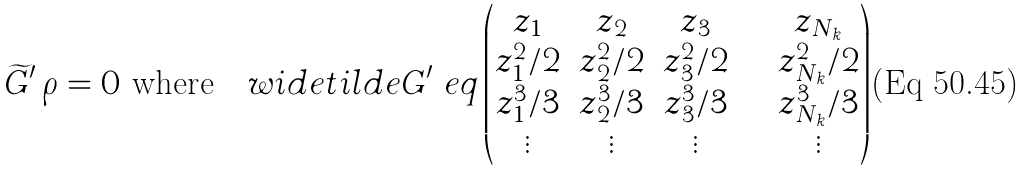<formula> <loc_0><loc_0><loc_500><loc_500>\widetilde { G } ^ { \prime } \, { \rho } = 0 \ { \text {where} } \ \ \ w i d e t i l d e { G } ^ { \prime } \ e q \begin{pmatrix} z _ { 1 } & z _ { 2 } & z _ { 3 } & \cdots & z _ { N _ { k } } \\ z _ { 1 } ^ { 2 } / 2 & z _ { 2 } ^ { 2 } / 2 & z _ { 3 } ^ { 2 } / 2 & \cdots & z _ { N _ { k } } ^ { 2 } / 2 \\ z _ { 1 } ^ { 3 } / 3 & z _ { 2 } ^ { 3 } / 3 & z _ { 3 } ^ { 3 } / 3 & \cdots & z _ { N _ { k } } ^ { 3 } / 3 \\ \vdots & \vdots & \vdots & & \vdots \end{pmatrix}</formula> 